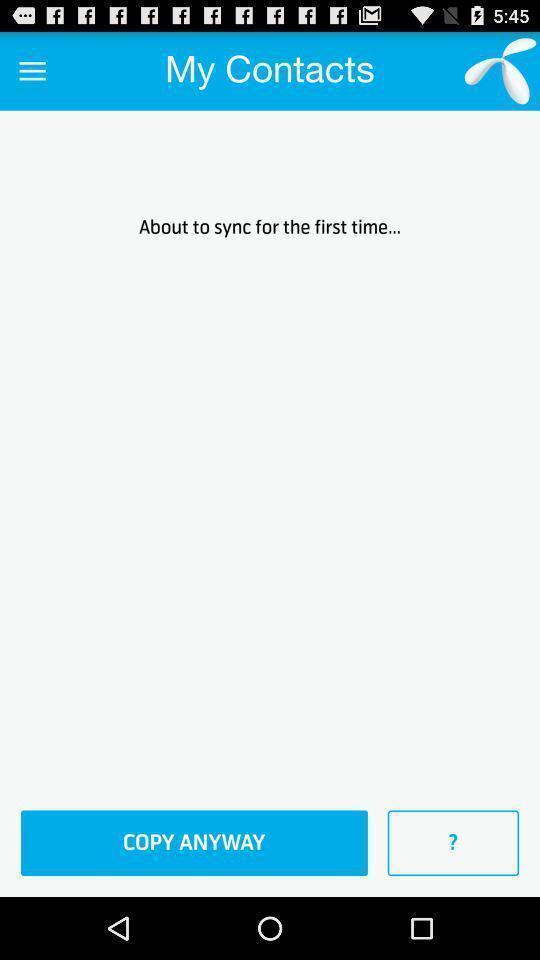Describe this image in words. Welcome page of a contacts app. 